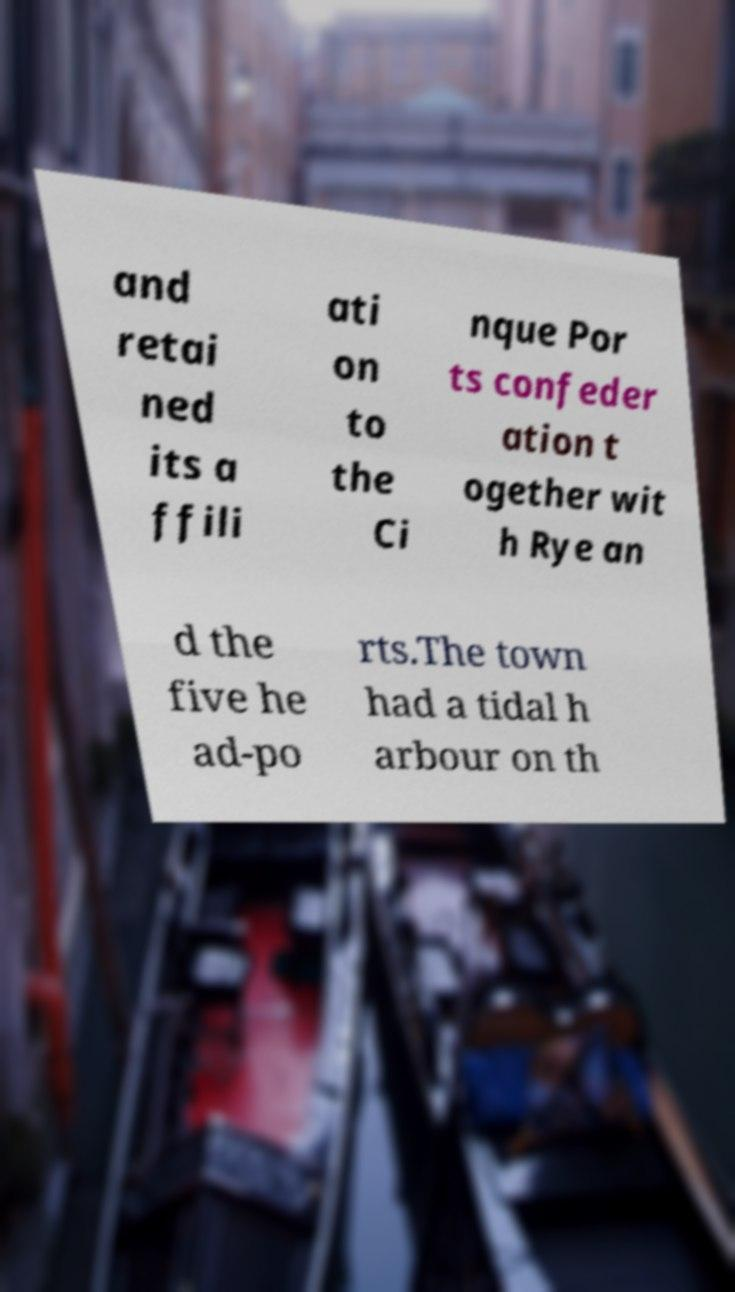For documentation purposes, I need the text within this image transcribed. Could you provide that? and retai ned its a ffili ati on to the Ci nque Por ts confeder ation t ogether wit h Rye an d the five he ad-po rts.The town had a tidal h arbour on th 